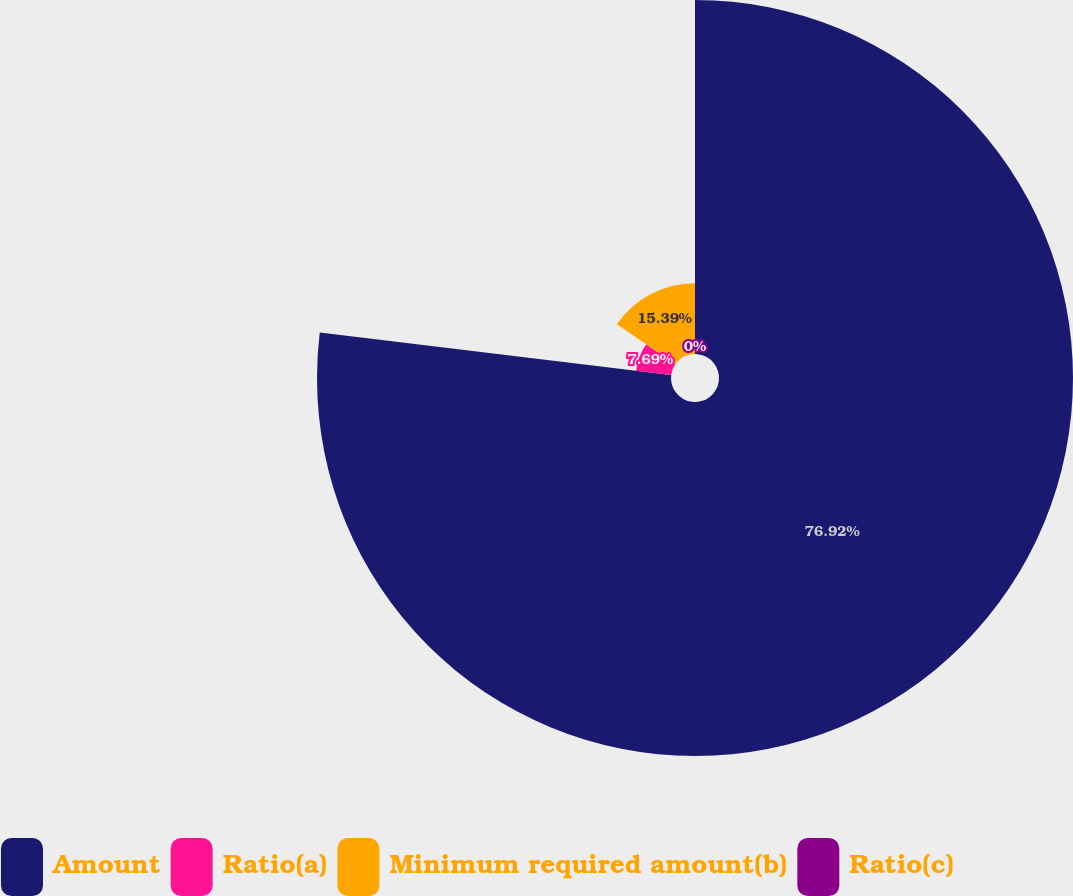Convert chart. <chart><loc_0><loc_0><loc_500><loc_500><pie_chart><fcel>Amount<fcel>Ratio(a)<fcel>Minimum required amount(b)<fcel>Ratio(c)<nl><fcel>76.92%<fcel>7.69%<fcel>15.39%<fcel>0.0%<nl></chart> 